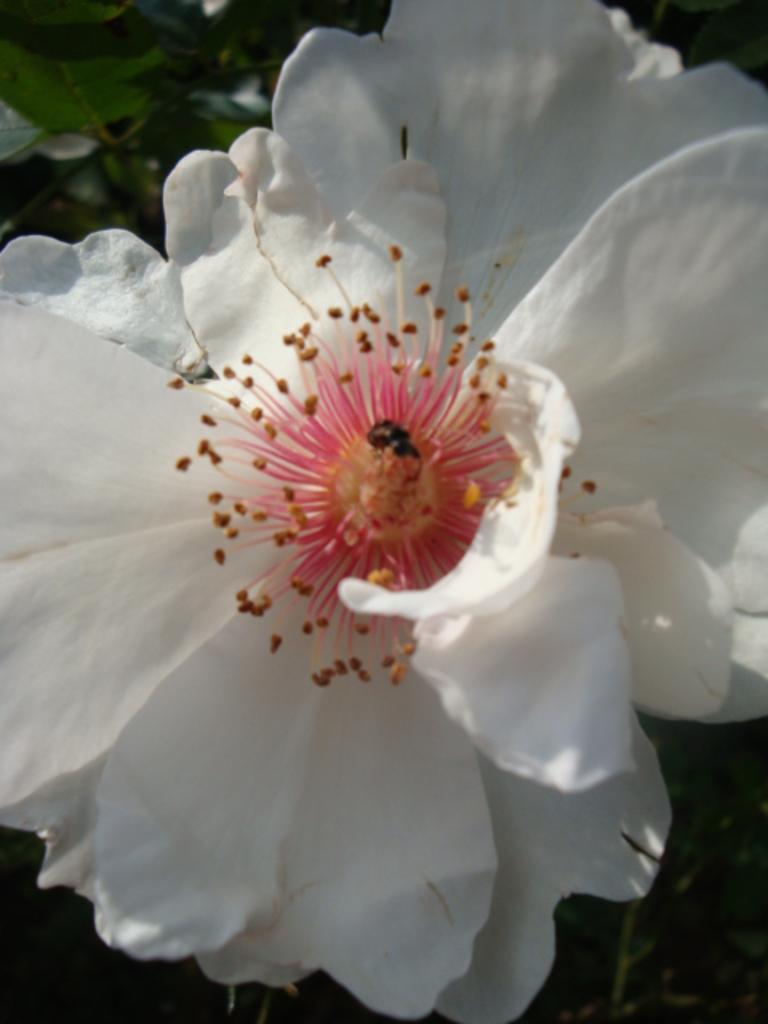Can you describe this image briefly? This image is taken outdoors. In the background there are a few plants. In the middle of the image there is a floor which is white in color. 